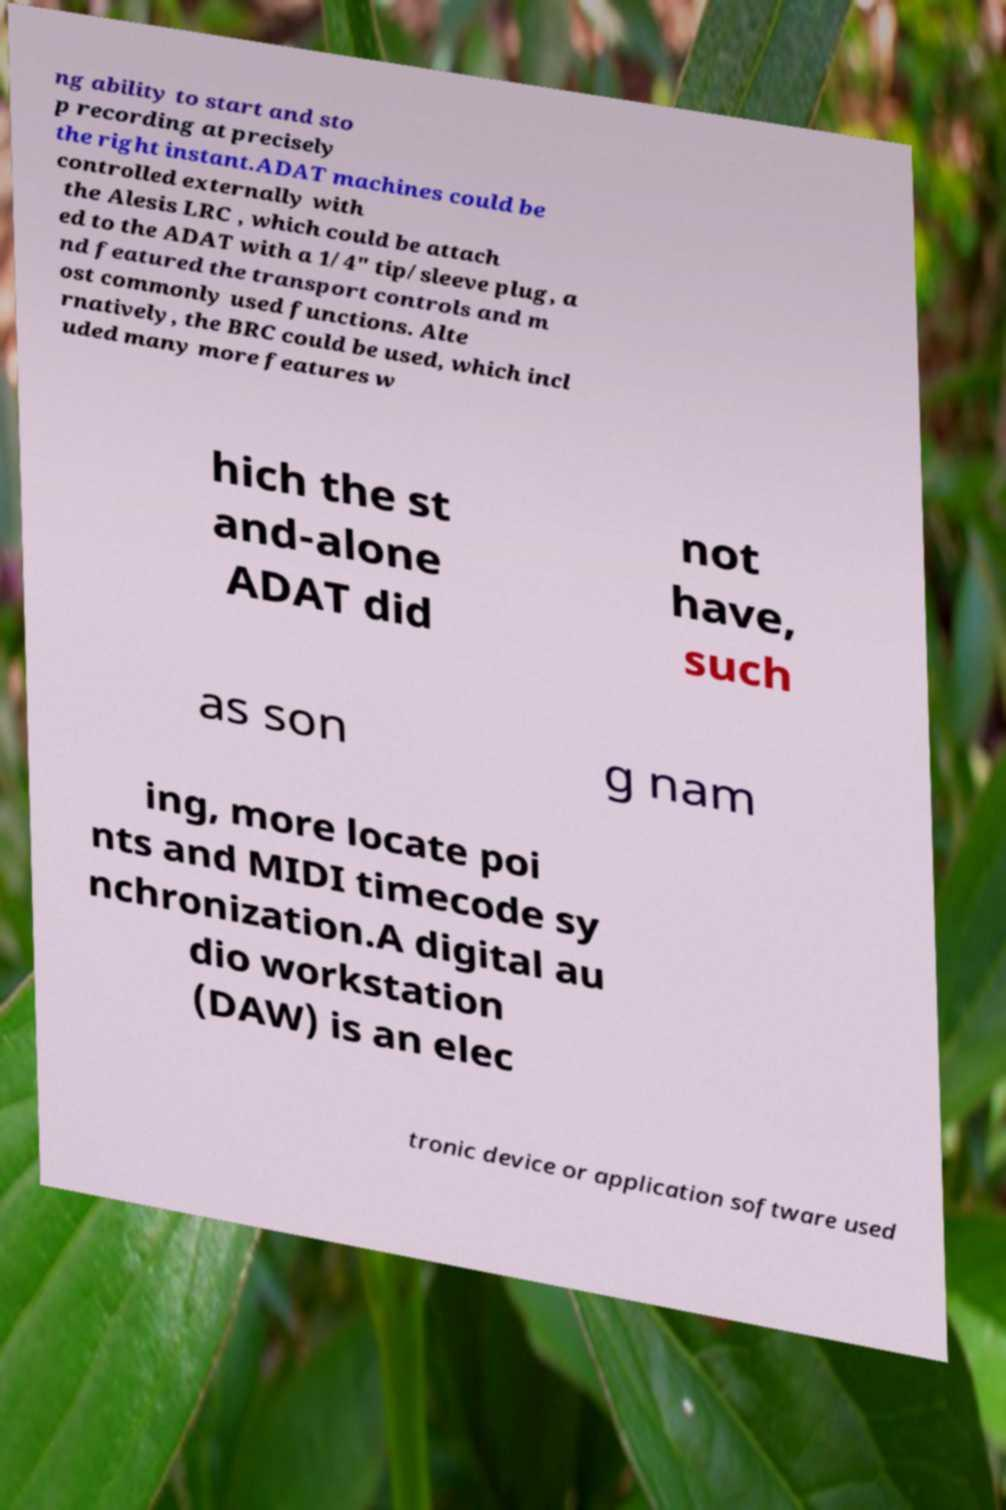For documentation purposes, I need the text within this image transcribed. Could you provide that? ng ability to start and sto p recording at precisely the right instant.ADAT machines could be controlled externally with the Alesis LRC , which could be attach ed to the ADAT with a 1/4" tip/sleeve plug, a nd featured the transport controls and m ost commonly used functions. Alte rnatively, the BRC could be used, which incl uded many more features w hich the st and-alone ADAT did not have, such as son g nam ing, more locate poi nts and MIDI timecode sy nchronization.A digital au dio workstation (DAW) is an elec tronic device or application software used 